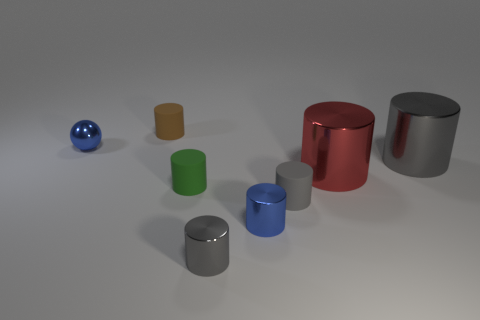Subtract all gray spheres. How many gray cylinders are left? 3 Subtract 4 cylinders. How many cylinders are left? 3 Subtract all brown matte cylinders. How many cylinders are left? 6 Subtract all green cylinders. How many cylinders are left? 6 Add 1 red things. How many objects exist? 9 Subtract all yellow cylinders. Subtract all gray blocks. How many cylinders are left? 7 Subtract all cylinders. How many objects are left? 1 Subtract 0 red balls. How many objects are left? 8 Subtract all large gray cylinders. Subtract all big gray shiny cylinders. How many objects are left? 6 Add 7 brown rubber cylinders. How many brown rubber cylinders are left? 8 